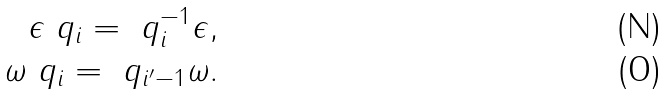<formula> <loc_0><loc_0><loc_500><loc_500>\epsilon \ q _ { i } = \ q _ { i } ^ { - 1 } \epsilon , \\ \omega \ q _ { i } = \ q _ { i ^ { \prime } - 1 } \omega .</formula> 